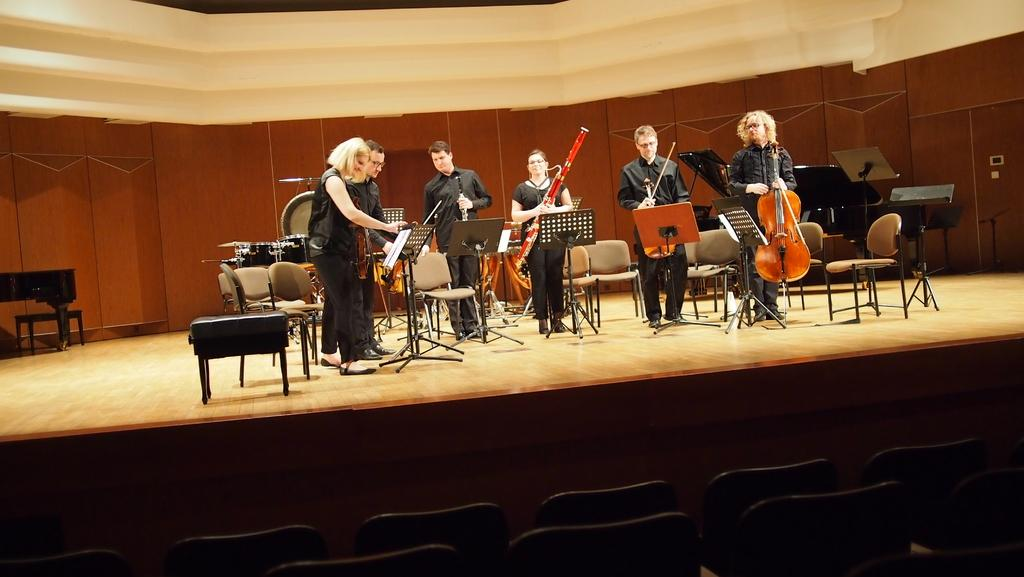What is present in the background of the image? There is a wall in the image. What are the people on stage doing? Some of the people on stage are holding guitars. What type of event might be taking place in the image? It could be a musical performance, as people are on stage holding guitars. How many apples are being used as volleyballs in the image? There are no apples or volleyballs present in the image. How many passengers are visible on the stage in the image? There are no passengers mentioned or visible in the image; it features people on a stage holding guitars. 